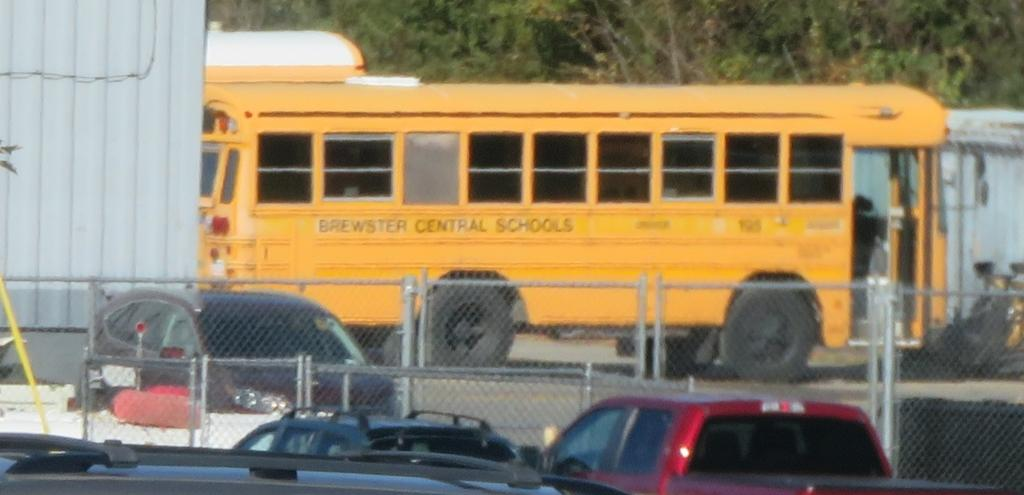<image>
Offer a succinct explanation of the picture presented. A Brewster Central School School Bus sitting around a bunch of cars. 